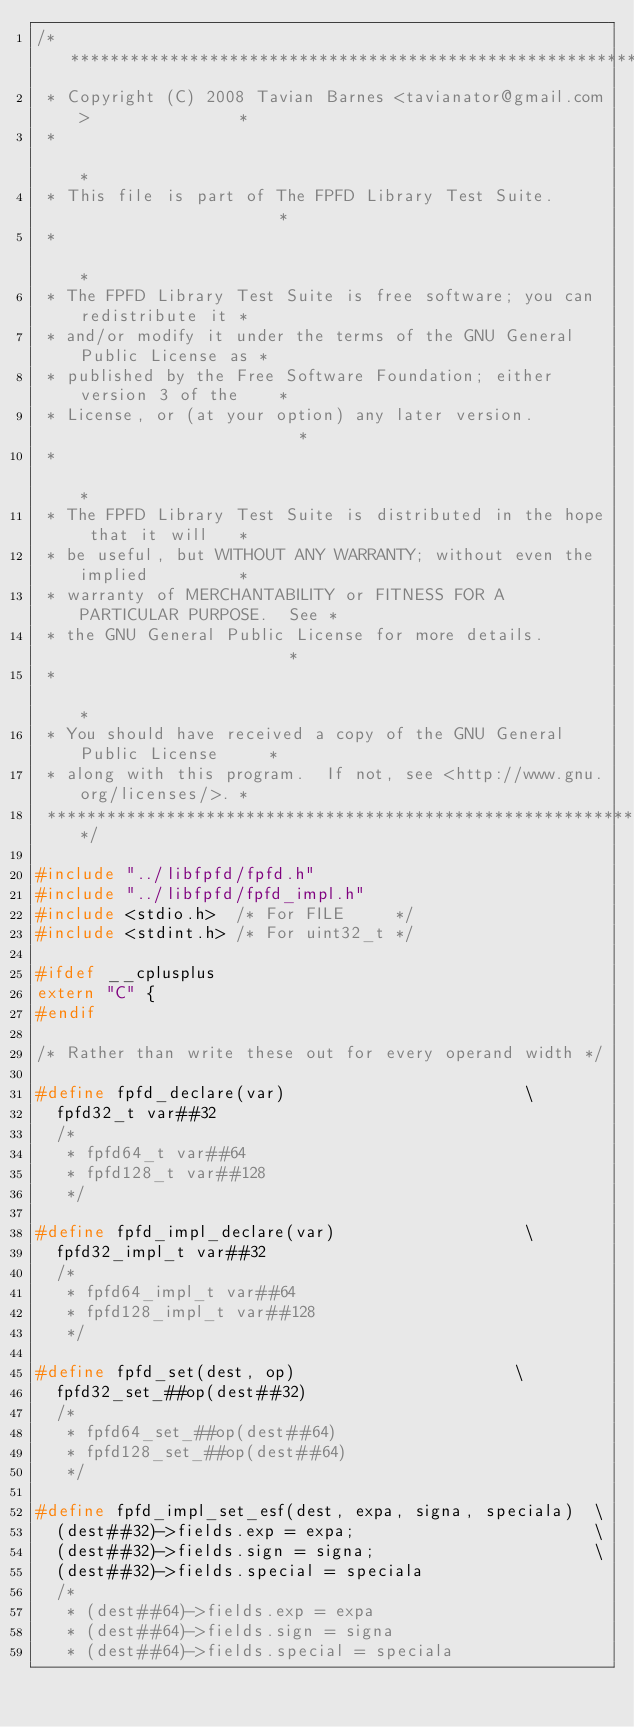<code> <loc_0><loc_0><loc_500><loc_500><_C_>/*************************************************************************
 * Copyright (C) 2008 Tavian Barnes <tavianator@gmail.com>               *
 *                                                                       *
 * This file is part of The FPFD Library Test Suite.                     *
 *                                                                       *
 * The FPFD Library Test Suite is free software; you can redistribute it *
 * and/or modify it under the terms of the GNU General Public License as *
 * published by the Free Software Foundation; either version 3 of the    *
 * License, or (at your option) any later version.                       *
 *                                                                       *
 * The FPFD Library Test Suite is distributed in the hope that it will   *
 * be useful, but WITHOUT ANY WARRANTY; without even the implied         *
 * warranty of MERCHANTABILITY or FITNESS FOR A PARTICULAR PURPOSE.  See *
 * the GNU General Public License for more details.                      *
 *                                                                       *
 * You should have received a copy of the GNU General Public License     *
 * along with this program.  If not, see <http://www.gnu.org/licenses/>. *
 *************************************************************************/

#include "../libfpfd/fpfd.h"
#include "../libfpfd/fpfd_impl.h"
#include <stdio.h>  /* For FILE     */
#include <stdint.h> /* For uint32_t */

#ifdef __cplusplus
extern "C" {
#endif

/* Rather than write these out for every operand width */

#define fpfd_declare(var)                        \
  fpfd32_t var##32
  /*
   * fpfd64_t var##64
   * fpfd128_t var##128
   */

#define fpfd_impl_declare(var)                   \
  fpfd32_impl_t var##32
  /*
   * fpfd64_impl_t var##64
   * fpfd128_impl_t var##128
   */

#define fpfd_set(dest, op)                      \
  fpfd32_set_##op(dest##32)
  /*
   * fpfd64_set_##op(dest##64)
   * fpfd128_set_##op(dest##64)
   */

#define fpfd_impl_set_esf(dest, expa, signa, speciala)  \
  (dest##32)->fields.exp = expa;                        \
  (dest##32)->fields.sign = signa;                      \
  (dest##32)->fields.special = speciala
  /*
   * (dest##64)->fields.exp = expa
   * (dest##64)->fields.sign = signa
   * (dest##64)->fields.special = speciala</code> 